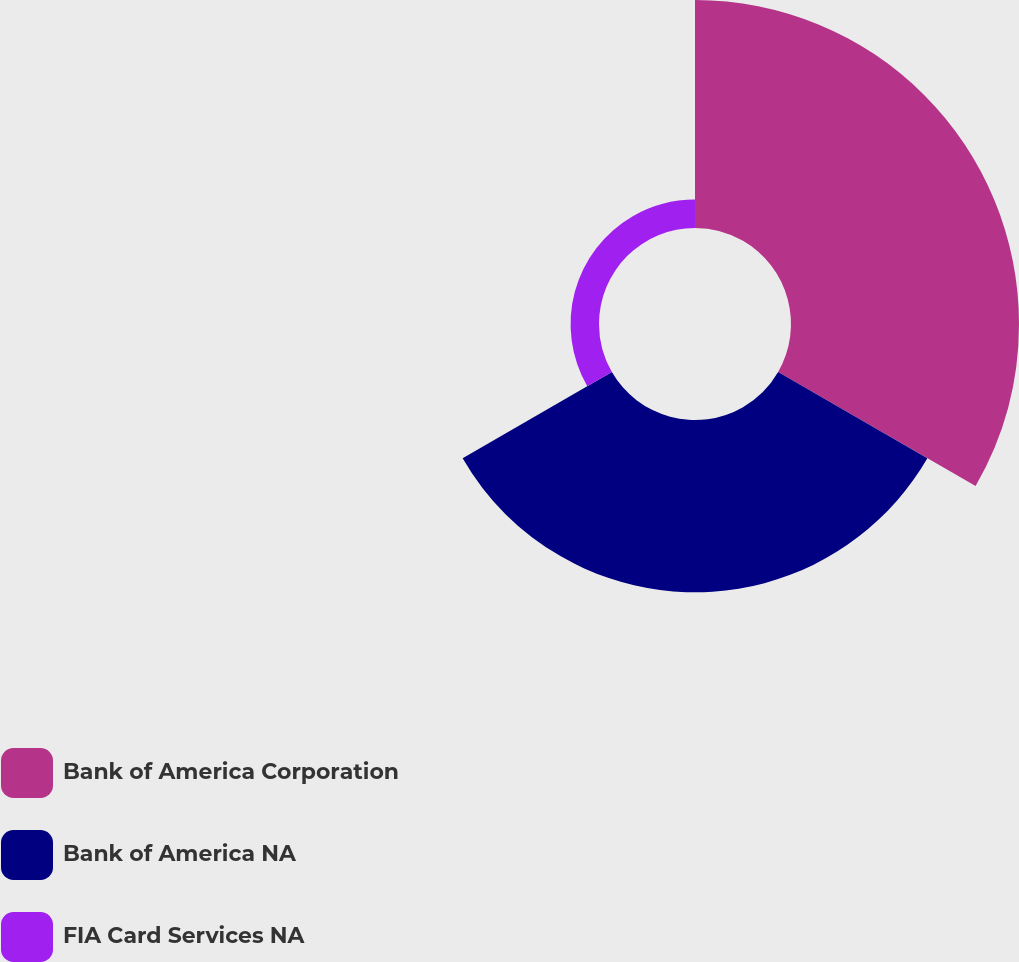<chart> <loc_0><loc_0><loc_500><loc_500><pie_chart><fcel>Bank of America Corporation<fcel>Bank of America NA<fcel>FIA Card Services NA<nl><fcel>53.18%<fcel>40.19%<fcel>6.63%<nl></chart> 